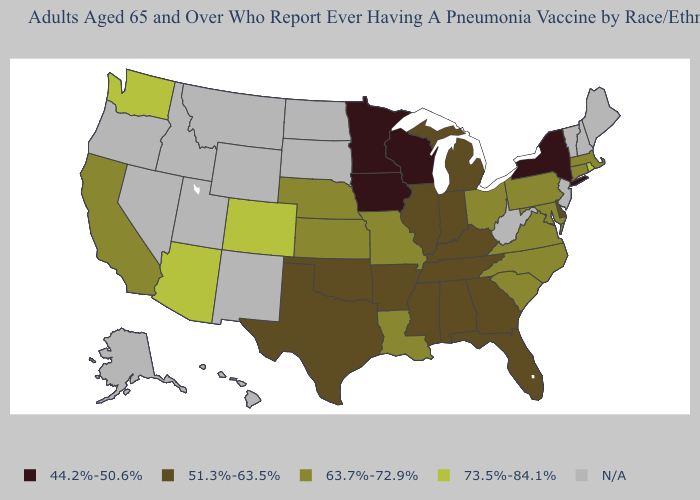Name the states that have a value in the range N/A?
Concise answer only. Alaska, Hawaii, Idaho, Maine, Montana, Nevada, New Hampshire, New Jersey, New Mexico, North Dakota, Oregon, South Dakota, Utah, Vermont, West Virginia, Wyoming. Name the states that have a value in the range 63.7%-72.9%?
Answer briefly. California, Connecticut, Kansas, Louisiana, Maryland, Massachusetts, Missouri, Nebraska, North Carolina, Ohio, Pennsylvania, South Carolina, Virginia. How many symbols are there in the legend?
Concise answer only. 5. What is the value of South Dakota?
Give a very brief answer. N/A. What is the value of Louisiana?
Concise answer only. 63.7%-72.9%. Among the states that border Louisiana , which have the highest value?
Short answer required. Arkansas, Mississippi, Texas. Does California have the lowest value in the West?
Quick response, please. Yes. What is the value of New York?
Quick response, please. 44.2%-50.6%. Name the states that have a value in the range 63.7%-72.9%?
Keep it brief. California, Connecticut, Kansas, Louisiana, Maryland, Massachusetts, Missouri, Nebraska, North Carolina, Ohio, Pennsylvania, South Carolina, Virginia. What is the highest value in the USA?
Quick response, please. 73.5%-84.1%. Name the states that have a value in the range 51.3%-63.5%?
Short answer required. Alabama, Arkansas, Delaware, Florida, Georgia, Illinois, Indiana, Kentucky, Michigan, Mississippi, Oklahoma, Tennessee, Texas. What is the lowest value in the Northeast?
Be succinct. 44.2%-50.6%. Does the first symbol in the legend represent the smallest category?
Write a very short answer. Yes. What is the value of Alabama?
Quick response, please. 51.3%-63.5%. 